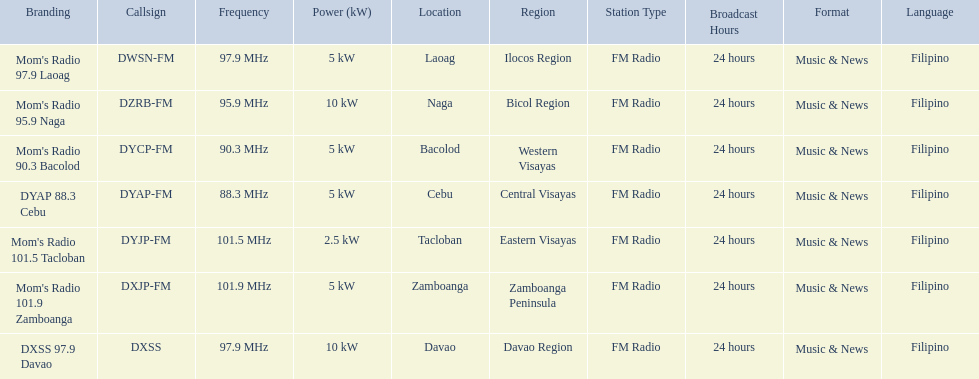What is the total number of stations with frequencies above 100 mhz? 2. 